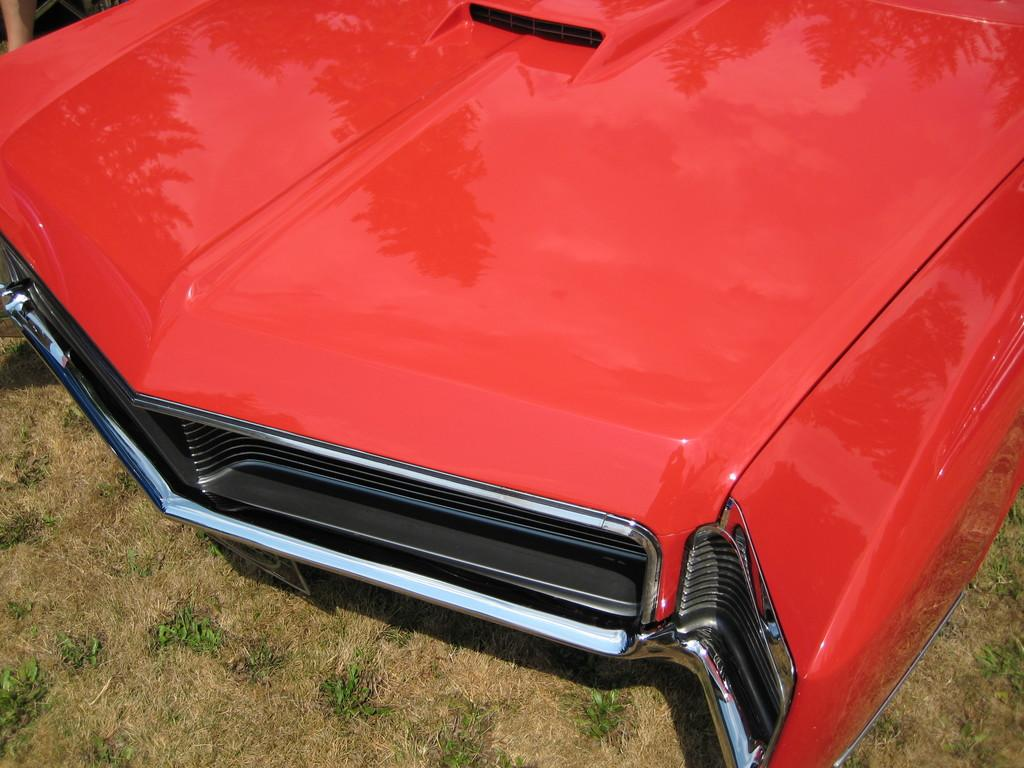What is the main subject of the image? The main subject of the image is a red color car. Can you describe the color of the car? The car is red. What type of terrain is visible at the bottom of the image? Grass is visible on the land at the bottom of the image. How long does it take for the car to cover a minute in the image? The concept of time or speed is not mentioned in the image, so it's not possible to determine how long it takes for the car to cover a minute. 